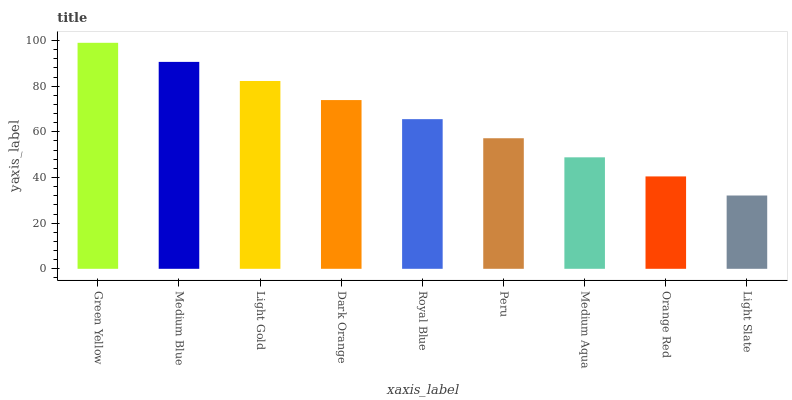Is Medium Blue the minimum?
Answer yes or no. No. Is Medium Blue the maximum?
Answer yes or no. No. Is Green Yellow greater than Medium Blue?
Answer yes or no. Yes. Is Medium Blue less than Green Yellow?
Answer yes or no. Yes. Is Medium Blue greater than Green Yellow?
Answer yes or no. No. Is Green Yellow less than Medium Blue?
Answer yes or no. No. Is Royal Blue the high median?
Answer yes or no. Yes. Is Royal Blue the low median?
Answer yes or no. Yes. Is Light Gold the high median?
Answer yes or no. No. Is Green Yellow the low median?
Answer yes or no. No. 